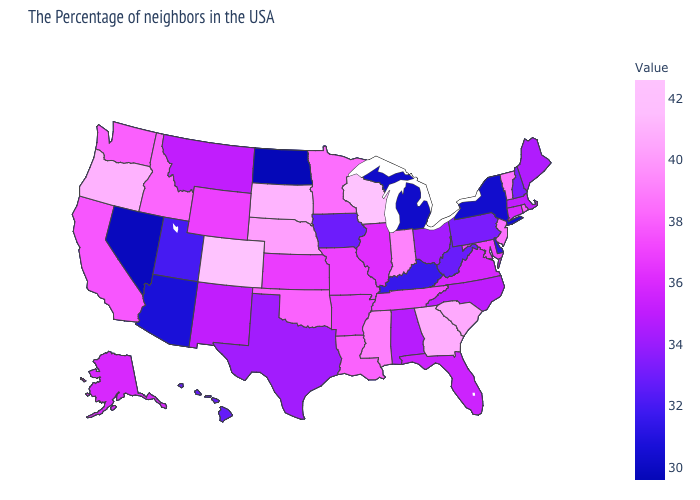Among the states that border Nevada , which have the highest value?
Write a very short answer. Oregon. Which states hav the highest value in the Northeast?
Keep it brief. Vermont. Among the states that border Tennessee , does Virginia have the highest value?
Short answer required. No. Which states have the lowest value in the West?
Keep it brief. Nevada. 